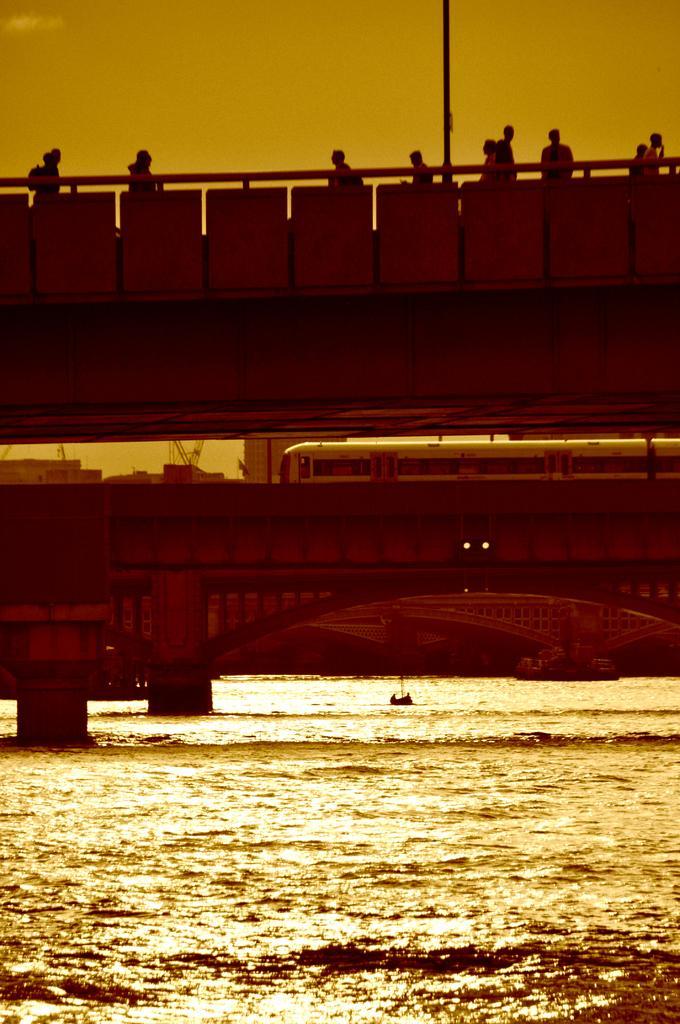Could you give a brief overview of what you see in this image? There is a surface of water at the bottom of this image, and we can see bridge, train, and some persons in the middle of this image, and there is a sky in the background. 